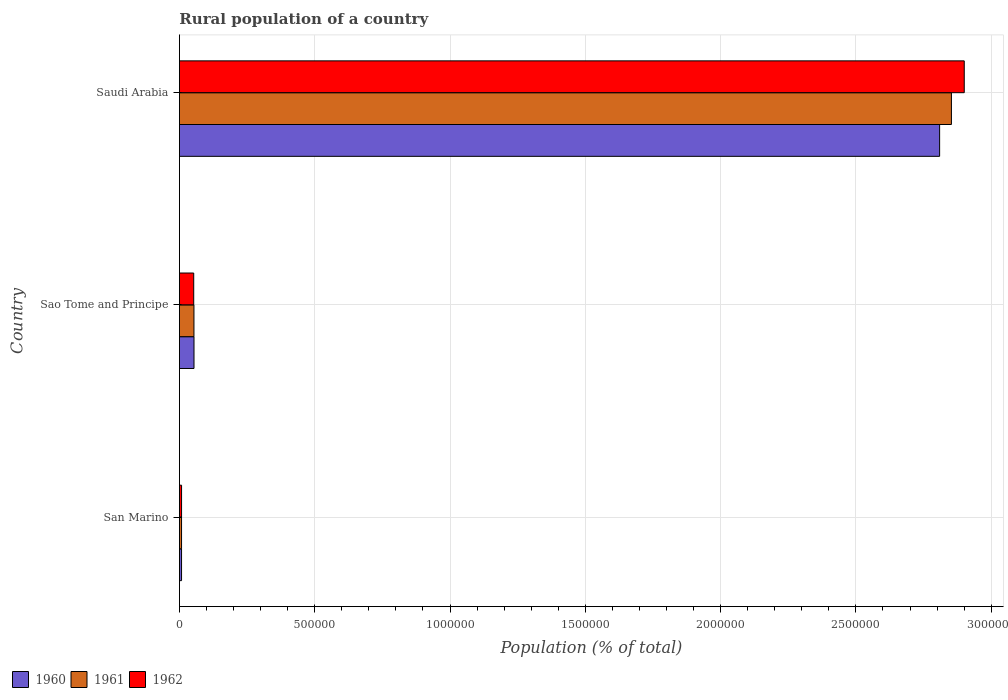How many groups of bars are there?
Make the answer very short. 3. How many bars are there on the 1st tick from the bottom?
Make the answer very short. 3. What is the label of the 2nd group of bars from the top?
Make the answer very short. Sao Tome and Principe. What is the rural population in 1962 in Sao Tome and Principe?
Keep it short and to the point. 5.29e+04. Across all countries, what is the maximum rural population in 1961?
Your answer should be very brief. 2.85e+06. Across all countries, what is the minimum rural population in 1960?
Your answer should be very brief. 7866. In which country was the rural population in 1962 maximum?
Give a very brief answer. Saudi Arabia. In which country was the rural population in 1961 minimum?
Keep it short and to the point. San Marino. What is the total rural population in 1962 in the graph?
Make the answer very short. 2.96e+06. What is the difference between the rural population in 1962 in Sao Tome and Principe and that in Saudi Arabia?
Offer a terse response. -2.85e+06. What is the difference between the rural population in 1961 in Saudi Arabia and the rural population in 1962 in Sao Tome and Principe?
Your answer should be very brief. 2.80e+06. What is the average rural population in 1960 per country?
Offer a terse response. 9.57e+05. What is the difference between the rural population in 1961 and rural population in 1962 in Sao Tome and Principe?
Give a very brief answer. 850. What is the ratio of the rural population in 1960 in San Marino to that in Saudi Arabia?
Keep it short and to the point. 0. Is the rural population in 1962 in San Marino less than that in Saudi Arabia?
Provide a short and direct response. Yes. What is the difference between the highest and the second highest rural population in 1961?
Your answer should be compact. 2.80e+06. What is the difference between the highest and the lowest rural population in 1961?
Your answer should be compact. 2.85e+06. Is the sum of the rural population in 1962 in San Marino and Saudi Arabia greater than the maximum rural population in 1960 across all countries?
Make the answer very short. Yes. What does the 2nd bar from the bottom in Sao Tome and Principe represents?
Give a very brief answer. 1961. Is it the case that in every country, the sum of the rural population in 1962 and rural population in 1961 is greater than the rural population in 1960?
Keep it short and to the point. Yes. How many countries are there in the graph?
Ensure brevity in your answer.  3. What is the difference between two consecutive major ticks on the X-axis?
Give a very brief answer. 5.00e+05. Does the graph contain any zero values?
Provide a succinct answer. No. Does the graph contain grids?
Make the answer very short. Yes. What is the title of the graph?
Keep it short and to the point. Rural population of a country. Does "1964" appear as one of the legend labels in the graph?
Ensure brevity in your answer.  No. What is the label or title of the X-axis?
Provide a succinct answer. Population (% of total). What is the Population (% of total) in 1960 in San Marino?
Offer a terse response. 7866. What is the Population (% of total) of 1961 in San Marino?
Provide a short and direct response. 7893. What is the Population (% of total) in 1962 in San Marino?
Your answer should be very brief. 7920. What is the Population (% of total) of 1960 in Sao Tome and Principe?
Offer a terse response. 5.39e+04. What is the Population (% of total) in 1961 in Sao Tome and Principe?
Your answer should be very brief. 5.37e+04. What is the Population (% of total) in 1962 in Sao Tome and Principe?
Give a very brief answer. 5.29e+04. What is the Population (% of total) in 1960 in Saudi Arabia?
Offer a terse response. 2.81e+06. What is the Population (% of total) of 1961 in Saudi Arabia?
Your answer should be very brief. 2.85e+06. What is the Population (% of total) of 1962 in Saudi Arabia?
Make the answer very short. 2.90e+06. Across all countries, what is the maximum Population (% of total) of 1960?
Your response must be concise. 2.81e+06. Across all countries, what is the maximum Population (% of total) in 1961?
Give a very brief answer. 2.85e+06. Across all countries, what is the maximum Population (% of total) in 1962?
Your answer should be compact. 2.90e+06. Across all countries, what is the minimum Population (% of total) in 1960?
Ensure brevity in your answer.  7866. Across all countries, what is the minimum Population (% of total) in 1961?
Offer a terse response. 7893. Across all countries, what is the minimum Population (% of total) in 1962?
Ensure brevity in your answer.  7920. What is the total Population (% of total) in 1960 in the graph?
Keep it short and to the point. 2.87e+06. What is the total Population (% of total) in 1961 in the graph?
Offer a terse response. 2.91e+06. What is the total Population (% of total) in 1962 in the graph?
Offer a very short reply. 2.96e+06. What is the difference between the Population (% of total) in 1960 in San Marino and that in Sao Tome and Principe?
Keep it short and to the point. -4.61e+04. What is the difference between the Population (% of total) in 1961 in San Marino and that in Sao Tome and Principe?
Offer a very short reply. -4.58e+04. What is the difference between the Population (% of total) in 1962 in San Marino and that in Sao Tome and Principe?
Your response must be concise. -4.49e+04. What is the difference between the Population (% of total) of 1960 in San Marino and that in Saudi Arabia?
Make the answer very short. -2.80e+06. What is the difference between the Population (% of total) in 1961 in San Marino and that in Saudi Arabia?
Your response must be concise. -2.85e+06. What is the difference between the Population (% of total) in 1962 in San Marino and that in Saudi Arabia?
Provide a short and direct response. -2.89e+06. What is the difference between the Population (% of total) of 1960 in Sao Tome and Principe and that in Saudi Arabia?
Provide a succinct answer. -2.76e+06. What is the difference between the Population (% of total) of 1961 in Sao Tome and Principe and that in Saudi Arabia?
Offer a terse response. -2.80e+06. What is the difference between the Population (% of total) in 1962 in Sao Tome and Principe and that in Saudi Arabia?
Your answer should be compact. -2.85e+06. What is the difference between the Population (% of total) of 1960 in San Marino and the Population (% of total) of 1961 in Sao Tome and Principe?
Keep it short and to the point. -4.58e+04. What is the difference between the Population (% of total) of 1960 in San Marino and the Population (% of total) of 1962 in Sao Tome and Principe?
Offer a very short reply. -4.50e+04. What is the difference between the Population (% of total) in 1961 in San Marino and the Population (% of total) in 1962 in Sao Tome and Principe?
Your response must be concise. -4.50e+04. What is the difference between the Population (% of total) of 1960 in San Marino and the Population (% of total) of 1961 in Saudi Arabia?
Provide a short and direct response. -2.85e+06. What is the difference between the Population (% of total) of 1960 in San Marino and the Population (% of total) of 1962 in Saudi Arabia?
Your answer should be very brief. -2.89e+06. What is the difference between the Population (% of total) in 1961 in San Marino and the Population (% of total) in 1962 in Saudi Arabia?
Offer a terse response. -2.89e+06. What is the difference between the Population (% of total) of 1960 in Sao Tome and Principe and the Population (% of total) of 1961 in Saudi Arabia?
Ensure brevity in your answer.  -2.80e+06. What is the difference between the Population (% of total) of 1960 in Sao Tome and Principe and the Population (% of total) of 1962 in Saudi Arabia?
Provide a short and direct response. -2.85e+06. What is the difference between the Population (% of total) in 1961 in Sao Tome and Principe and the Population (% of total) in 1962 in Saudi Arabia?
Provide a short and direct response. -2.85e+06. What is the average Population (% of total) of 1960 per country?
Ensure brevity in your answer.  9.57e+05. What is the average Population (% of total) in 1961 per country?
Make the answer very short. 9.72e+05. What is the average Population (% of total) of 1962 per country?
Keep it short and to the point. 9.87e+05. What is the difference between the Population (% of total) in 1960 and Population (% of total) in 1961 in San Marino?
Your answer should be compact. -27. What is the difference between the Population (% of total) of 1960 and Population (% of total) of 1962 in San Marino?
Your answer should be compact. -54. What is the difference between the Population (% of total) of 1960 and Population (% of total) of 1961 in Sao Tome and Principe?
Ensure brevity in your answer.  225. What is the difference between the Population (% of total) of 1960 and Population (% of total) of 1962 in Sao Tome and Principe?
Your response must be concise. 1075. What is the difference between the Population (% of total) of 1961 and Population (% of total) of 1962 in Sao Tome and Principe?
Ensure brevity in your answer.  850. What is the difference between the Population (% of total) of 1960 and Population (% of total) of 1961 in Saudi Arabia?
Ensure brevity in your answer.  -4.36e+04. What is the difference between the Population (% of total) of 1960 and Population (% of total) of 1962 in Saudi Arabia?
Keep it short and to the point. -9.10e+04. What is the difference between the Population (% of total) of 1961 and Population (% of total) of 1962 in Saudi Arabia?
Give a very brief answer. -4.74e+04. What is the ratio of the Population (% of total) of 1960 in San Marino to that in Sao Tome and Principe?
Keep it short and to the point. 0.15. What is the ratio of the Population (% of total) in 1961 in San Marino to that in Sao Tome and Principe?
Ensure brevity in your answer.  0.15. What is the ratio of the Population (% of total) of 1962 in San Marino to that in Sao Tome and Principe?
Offer a very short reply. 0.15. What is the ratio of the Population (% of total) of 1960 in San Marino to that in Saudi Arabia?
Your response must be concise. 0. What is the ratio of the Population (% of total) of 1961 in San Marino to that in Saudi Arabia?
Offer a terse response. 0. What is the ratio of the Population (% of total) of 1962 in San Marino to that in Saudi Arabia?
Make the answer very short. 0. What is the ratio of the Population (% of total) of 1960 in Sao Tome and Principe to that in Saudi Arabia?
Your answer should be very brief. 0.02. What is the ratio of the Population (% of total) in 1961 in Sao Tome and Principe to that in Saudi Arabia?
Your answer should be compact. 0.02. What is the ratio of the Population (% of total) in 1962 in Sao Tome and Principe to that in Saudi Arabia?
Make the answer very short. 0.02. What is the difference between the highest and the second highest Population (% of total) of 1960?
Keep it short and to the point. 2.76e+06. What is the difference between the highest and the second highest Population (% of total) in 1961?
Ensure brevity in your answer.  2.80e+06. What is the difference between the highest and the second highest Population (% of total) in 1962?
Provide a short and direct response. 2.85e+06. What is the difference between the highest and the lowest Population (% of total) in 1960?
Your answer should be very brief. 2.80e+06. What is the difference between the highest and the lowest Population (% of total) of 1961?
Offer a terse response. 2.85e+06. What is the difference between the highest and the lowest Population (% of total) of 1962?
Provide a short and direct response. 2.89e+06. 